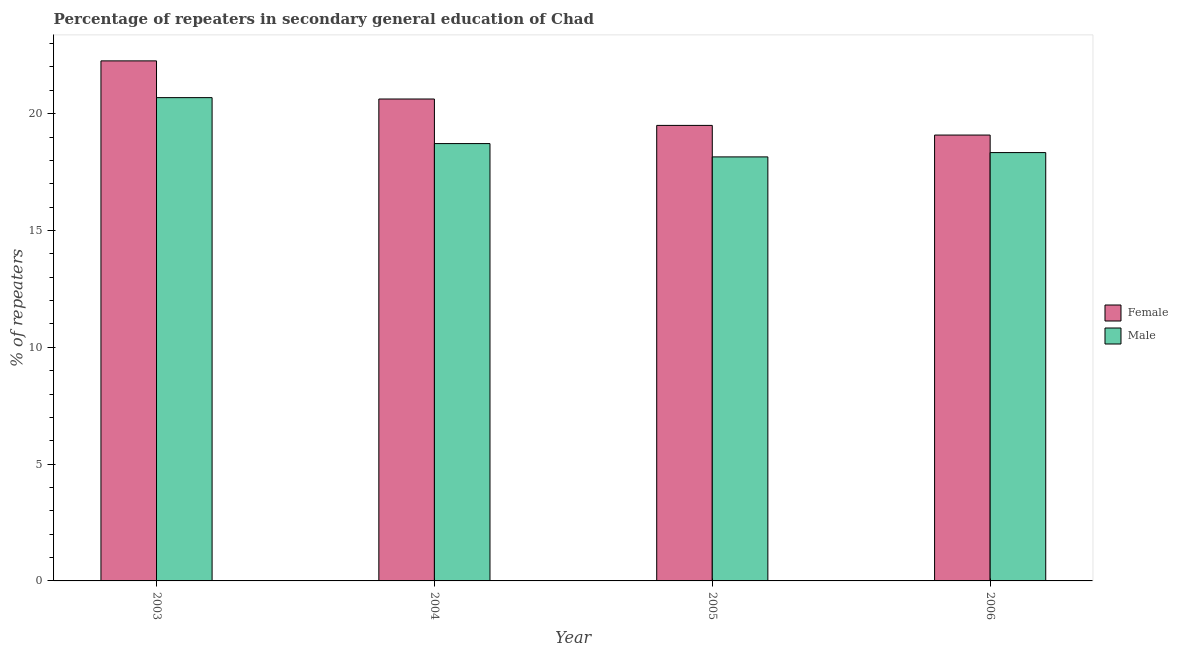How many different coloured bars are there?
Your response must be concise. 2. Are the number of bars per tick equal to the number of legend labels?
Provide a short and direct response. Yes. What is the percentage of female repeaters in 2003?
Provide a short and direct response. 22.26. Across all years, what is the maximum percentage of female repeaters?
Ensure brevity in your answer.  22.26. Across all years, what is the minimum percentage of female repeaters?
Offer a terse response. 19.09. What is the total percentage of female repeaters in the graph?
Give a very brief answer. 81.47. What is the difference between the percentage of male repeaters in 2004 and that in 2006?
Give a very brief answer. 0.39. What is the difference between the percentage of female repeaters in 2006 and the percentage of male repeaters in 2004?
Your response must be concise. -1.54. What is the average percentage of female repeaters per year?
Give a very brief answer. 20.37. In the year 2006, what is the difference between the percentage of female repeaters and percentage of male repeaters?
Provide a short and direct response. 0. What is the ratio of the percentage of female repeaters in 2004 to that in 2005?
Offer a terse response. 1.06. Is the percentage of female repeaters in 2005 less than that in 2006?
Keep it short and to the point. No. What is the difference between the highest and the second highest percentage of female repeaters?
Keep it short and to the point. 1.63. What is the difference between the highest and the lowest percentage of female repeaters?
Your response must be concise. 3.18. In how many years, is the percentage of female repeaters greater than the average percentage of female repeaters taken over all years?
Provide a succinct answer. 2. What does the 1st bar from the right in 2006 represents?
Provide a short and direct response. Male. What is the difference between two consecutive major ticks on the Y-axis?
Your answer should be compact. 5. Where does the legend appear in the graph?
Your answer should be very brief. Center right. How many legend labels are there?
Give a very brief answer. 2. What is the title of the graph?
Offer a very short reply. Percentage of repeaters in secondary general education of Chad. What is the label or title of the X-axis?
Your answer should be very brief. Year. What is the label or title of the Y-axis?
Ensure brevity in your answer.  % of repeaters. What is the % of repeaters of Female in 2003?
Provide a succinct answer. 22.26. What is the % of repeaters of Male in 2003?
Offer a terse response. 20.69. What is the % of repeaters in Female in 2004?
Provide a succinct answer. 20.63. What is the % of repeaters in Male in 2004?
Provide a short and direct response. 18.72. What is the % of repeaters in Female in 2005?
Offer a very short reply. 19.5. What is the % of repeaters in Male in 2005?
Keep it short and to the point. 18.15. What is the % of repeaters in Female in 2006?
Ensure brevity in your answer.  19.09. What is the % of repeaters in Male in 2006?
Provide a short and direct response. 18.33. Across all years, what is the maximum % of repeaters in Female?
Give a very brief answer. 22.26. Across all years, what is the maximum % of repeaters in Male?
Your answer should be very brief. 20.69. Across all years, what is the minimum % of repeaters of Female?
Offer a terse response. 19.09. Across all years, what is the minimum % of repeaters in Male?
Provide a succinct answer. 18.15. What is the total % of repeaters in Female in the graph?
Offer a very short reply. 81.47. What is the total % of repeaters in Male in the graph?
Your answer should be very brief. 75.89. What is the difference between the % of repeaters in Female in 2003 and that in 2004?
Ensure brevity in your answer.  1.63. What is the difference between the % of repeaters of Male in 2003 and that in 2004?
Make the answer very short. 1.97. What is the difference between the % of repeaters in Female in 2003 and that in 2005?
Your answer should be compact. 2.76. What is the difference between the % of repeaters in Male in 2003 and that in 2005?
Offer a very short reply. 2.54. What is the difference between the % of repeaters of Female in 2003 and that in 2006?
Make the answer very short. 3.18. What is the difference between the % of repeaters in Male in 2003 and that in 2006?
Your response must be concise. 2.35. What is the difference between the % of repeaters in Female in 2004 and that in 2005?
Your response must be concise. 1.13. What is the difference between the % of repeaters in Male in 2004 and that in 2005?
Keep it short and to the point. 0.57. What is the difference between the % of repeaters of Female in 2004 and that in 2006?
Give a very brief answer. 1.54. What is the difference between the % of repeaters in Male in 2004 and that in 2006?
Your answer should be compact. 0.39. What is the difference between the % of repeaters in Female in 2005 and that in 2006?
Your response must be concise. 0.41. What is the difference between the % of repeaters of Male in 2005 and that in 2006?
Ensure brevity in your answer.  -0.18. What is the difference between the % of repeaters in Female in 2003 and the % of repeaters in Male in 2004?
Ensure brevity in your answer.  3.54. What is the difference between the % of repeaters of Female in 2003 and the % of repeaters of Male in 2005?
Ensure brevity in your answer.  4.11. What is the difference between the % of repeaters of Female in 2003 and the % of repeaters of Male in 2006?
Ensure brevity in your answer.  3.93. What is the difference between the % of repeaters in Female in 2004 and the % of repeaters in Male in 2005?
Provide a short and direct response. 2.48. What is the difference between the % of repeaters of Female in 2004 and the % of repeaters of Male in 2006?
Ensure brevity in your answer.  2.29. What is the difference between the % of repeaters of Female in 2005 and the % of repeaters of Male in 2006?
Your response must be concise. 1.16. What is the average % of repeaters in Female per year?
Make the answer very short. 20.37. What is the average % of repeaters of Male per year?
Your response must be concise. 18.97. In the year 2003, what is the difference between the % of repeaters of Female and % of repeaters of Male?
Offer a very short reply. 1.57. In the year 2004, what is the difference between the % of repeaters of Female and % of repeaters of Male?
Provide a succinct answer. 1.91. In the year 2005, what is the difference between the % of repeaters in Female and % of repeaters in Male?
Give a very brief answer. 1.35. In the year 2006, what is the difference between the % of repeaters in Female and % of repeaters in Male?
Give a very brief answer. 0.75. What is the ratio of the % of repeaters in Female in 2003 to that in 2004?
Keep it short and to the point. 1.08. What is the ratio of the % of repeaters of Male in 2003 to that in 2004?
Give a very brief answer. 1.11. What is the ratio of the % of repeaters in Female in 2003 to that in 2005?
Offer a very short reply. 1.14. What is the ratio of the % of repeaters of Male in 2003 to that in 2005?
Make the answer very short. 1.14. What is the ratio of the % of repeaters of Female in 2003 to that in 2006?
Provide a succinct answer. 1.17. What is the ratio of the % of repeaters in Male in 2003 to that in 2006?
Provide a succinct answer. 1.13. What is the ratio of the % of repeaters in Female in 2004 to that in 2005?
Make the answer very short. 1.06. What is the ratio of the % of repeaters of Male in 2004 to that in 2005?
Offer a terse response. 1.03. What is the ratio of the % of repeaters in Female in 2004 to that in 2006?
Provide a succinct answer. 1.08. What is the ratio of the % of repeaters of Male in 2004 to that in 2006?
Your answer should be very brief. 1.02. What is the ratio of the % of repeaters of Female in 2005 to that in 2006?
Keep it short and to the point. 1.02. What is the difference between the highest and the second highest % of repeaters in Female?
Provide a short and direct response. 1.63. What is the difference between the highest and the second highest % of repeaters in Male?
Your answer should be compact. 1.97. What is the difference between the highest and the lowest % of repeaters in Female?
Your answer should be compact. 3.18. What is the difference between the highest and the lowest % of repeaters in Male?
Provide a short and direct response. 2.54. 